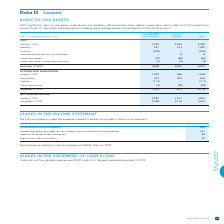According to Bce's financial document, What are BCE's significant right-of-use assets under leases? satellites, office premises, land, cellular tower sites, retail outlets and OOH advertising spaces. The document states: "significant right-of-use assets under leases are satellites, office premises, land, cellular tower sites, retail outlets and OOH advertising spaces. R..." Also, Where are the right-of-use assets presented? presented in Property, plant and equipment in the statement of financial position. The document states: "d OOH advertising spaces. Right-of-use assets are presented in Property, plant and equipment in the statement of financial position...." Also, What is the total net carrying amount on December 31, 2019? According to the financial document, 4,424. The relevant text states: "December 31, 2019 2,308 2,116 4,424..." Also, can you calculate: What is the percentage of total additions over the total costs of the right-of-use assets? Based on the calculation: 1,040/6,542, the result is 15.9 (percentage). This is based on the information: "Additions 527 513 1,040 December 31, 2019 3,609 2,933 6,542..." The key data points involved are: 1,040, 6,542. Also, can you calculate: What is the change in the total net carrying amount in 2019? Based on the calculation: 4,424-4,204, the result is 220. This is based on the information: "January 1, 2019 2,287 1,917 4,204 December 31, 2019 2,308 2,116 4,424..." The key data points involved are: 4,204, 4,424. Also, can you calculate: What is the change in the total accumulated depreciation in 2019? Based on the calculation: 2,118-1,578, the result is 540. This is based on the information: "December 31, 2019 1,301 817 2,118 January 1, 2019 1,042 536 1,578..." The key data points involved are: 1,578, 2,118. 